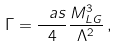<formula> <loc_0><loc_0><loc_500><loc_500>\Gamma = \frac { \ a s } { 4 } \frac { M _ { L G } ^ { 3 } } { \Lambda ^ { 2 } } \, ,</formula> 